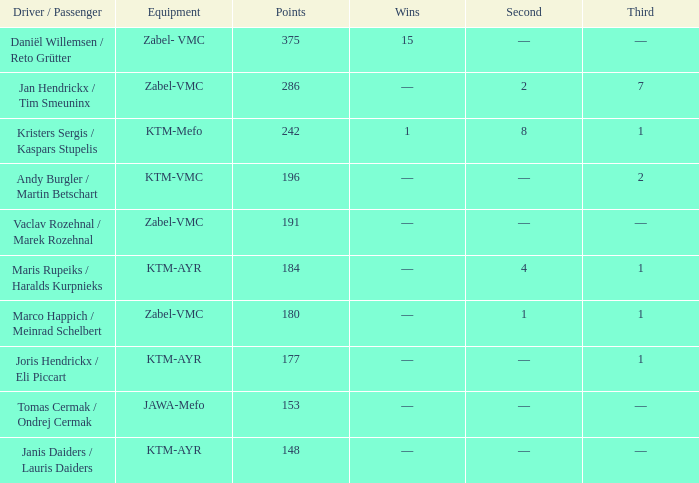Parse the table in full. {'header': ['Driver / Passenger', 'Equipment', 'Points', 'Wins', 'Second', 'Third'], 'rows': [['Daniël Willemsen / Reto Grütter', 'Zabel- VMC', '375', '15', '—', '—'], ['Jan Hendrickx / Tim Smeuninx', 'Zabel-VMC', '286', '—', '2', '7'], ['Kristers Sergis / Kaspars Stupelis', 'KTM-Mefo', '242', '1', '8', '1'], ['Andy Burgler / Martin Betschart', 'KTM-VMC', '196', '—', '—', '2'], ['Vaclav Rozehnal / Marek Rozehnal', 'Zabel-VMC', '191', '—', '—', '—'], ['Maris Rupeiks / Haralds Kurpnieks', 'KTM-AYR', '184', '—', '4', '1'], ['Marco Happich / Meinrad Schelbert', 'Zabel-VMC', '180', '—', '1', '1'], ['Joris Hendrickx / Eli Piccart', 'KTM-AYR', '177', '—', '—', '1'], ['Tomas Cermak / Ondrej Cermak', 'JAWA-Mefo', '153', '—', '—', '—'], ['Janis Daiders / Lauris Daiders', 'KTM-AYR', '148', '—', '—', '—']]} What was the highest points when the second was 4? 184.0. 